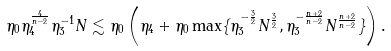Convert formula to latex. <formula><loc_0><loc_0><loc_500><loc_500>\eta _ { 0 } \eta _ { 4 } ^ { \frac { 4 } { n - 2 } } \eta _ { 3 } ^ { - 1 } N \lesssim \eta _ { 0 } \left ( \eta _ { 4 } + \eta _ { 0 } \max \{ \eta _ { 3 } ^ { - \frac { 3 } { 2 } } N ^ { \frac { 3 } { 2 } } , \eta _ { 3 } ^ { - \frac { n + 2 } { n - 2 } } N ^ { \frac { n + 2 } { n - 2 } } \} \right ) .</formula> 